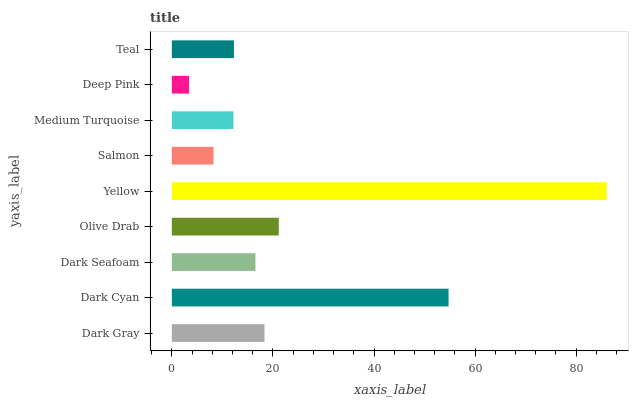Is Deep Pink the minimum?
Answer yes or no. Yes. Is Yellow the maximum?
Answer yes or no. Yes. Is Dark Cyan the minimum?
Answer yes or no. No. Is Dark Cyan the maximum?
Answer yes or no. No. Is Dark Cyan greater than Dark Gray?
Answer yes or no. Yes. Is Dark Gray less than Dark Cyan?
Answer yes or no. Yes. Is Dark Gray greater than Dark Cyan?
Answer yes or no. No. Is Dark Cyan less than Dark Gray?
Answer yes or no. No. Is Dark Seafoam the high median?
Answer yes or no. Yes. Is Dark Seafoam the low median?
Answer yes or no. Yes. Is Olive Drab the high median?
Answer yes or no. No. Is Salmon the low median?
Answer yes or no. No. 